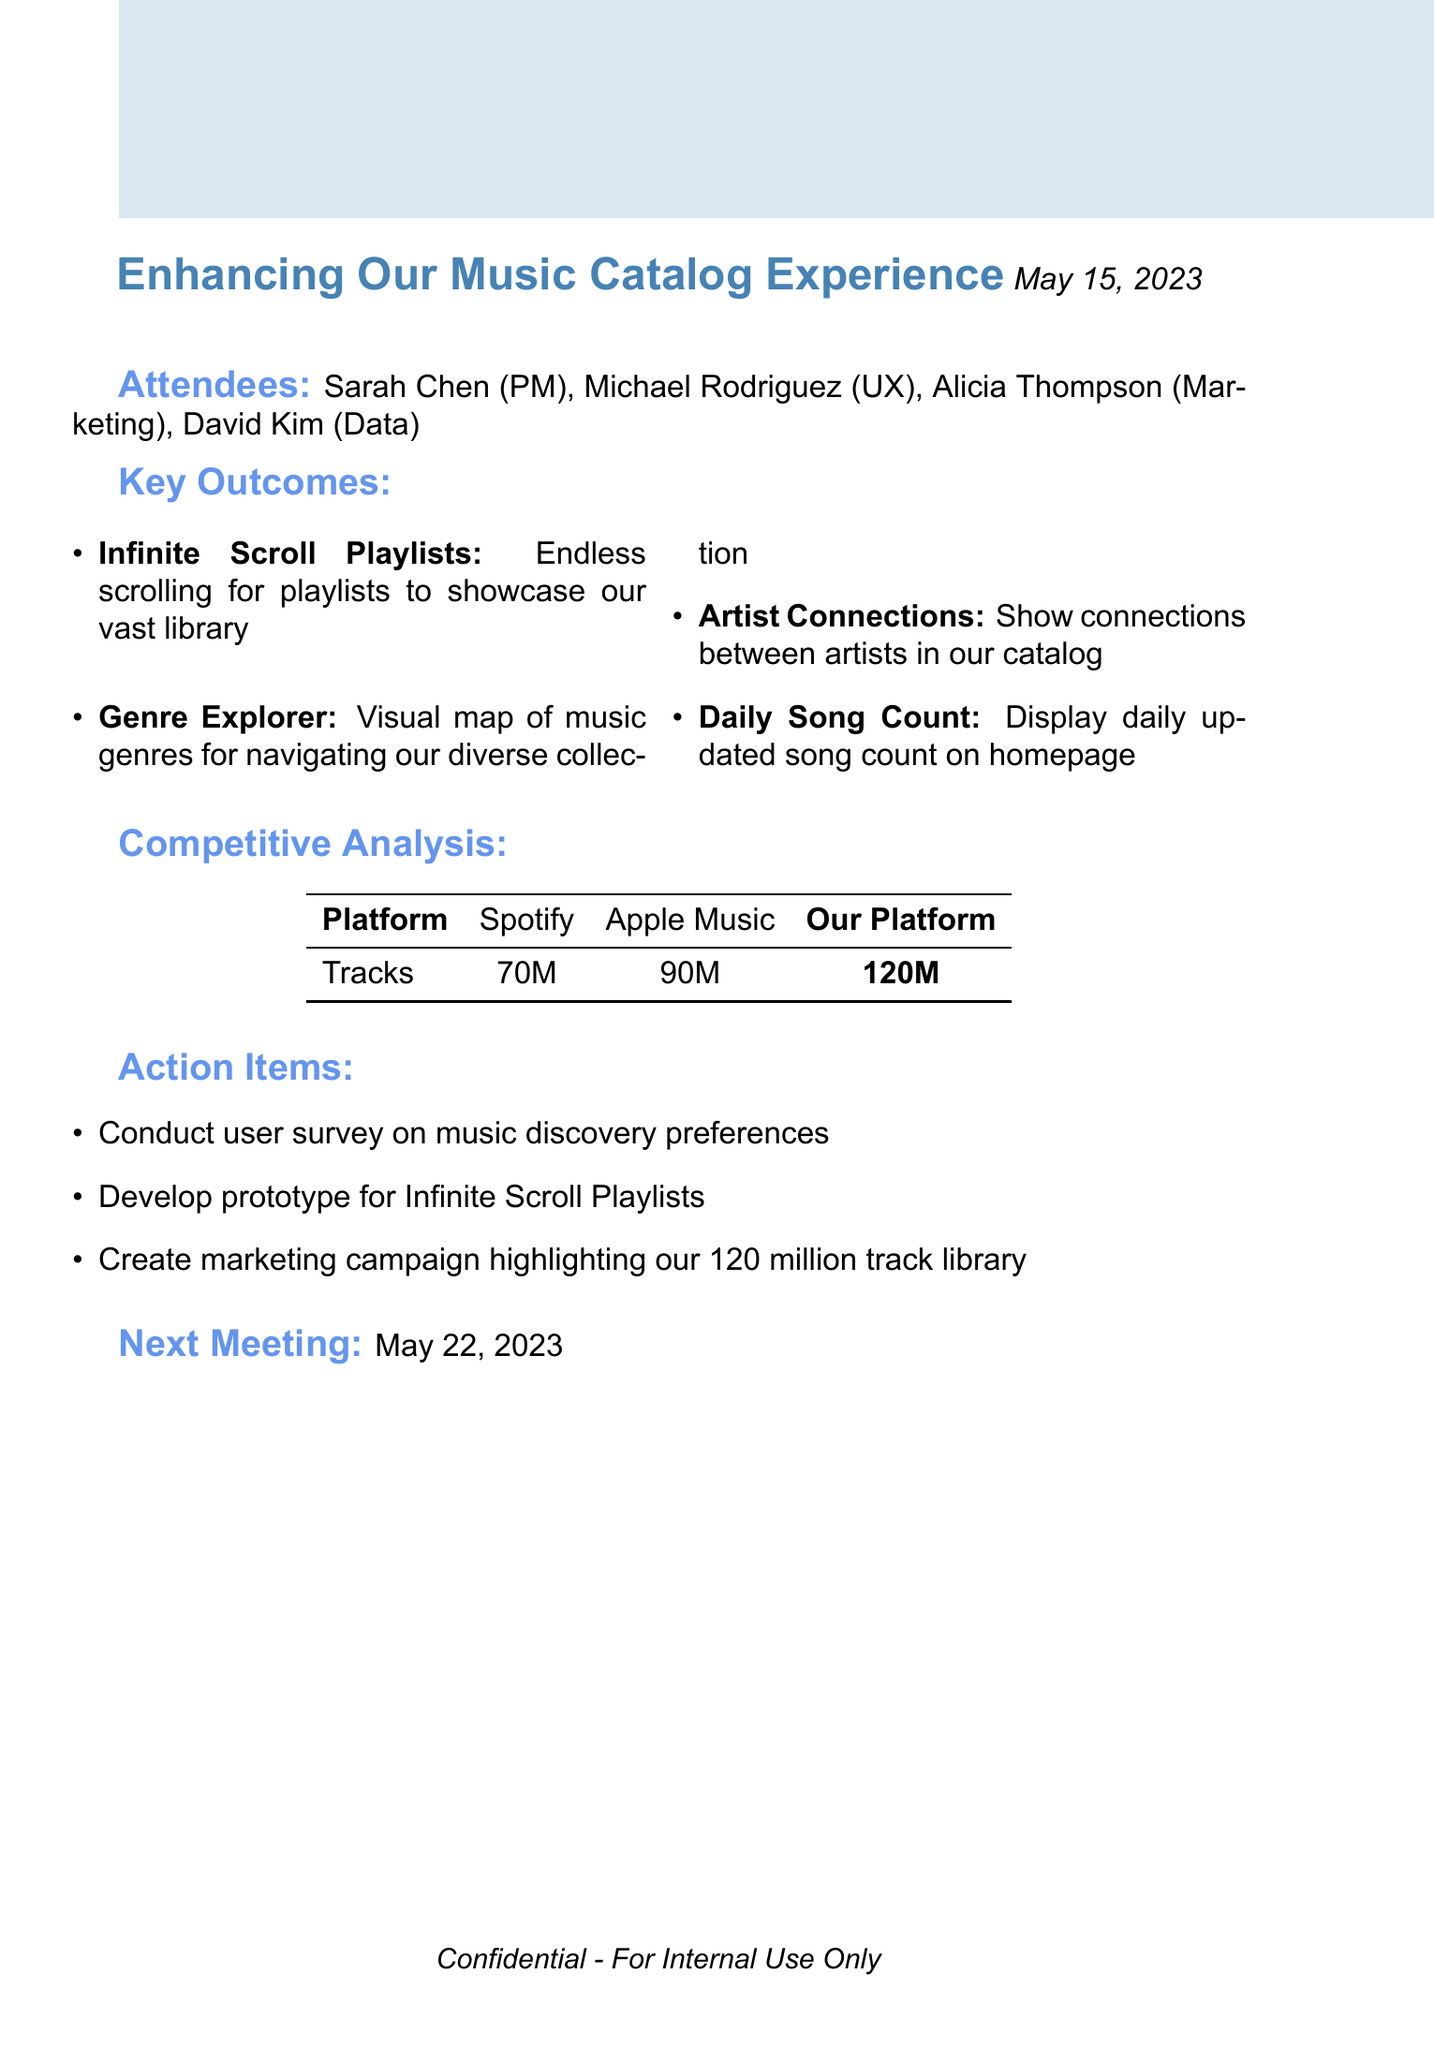What is the session title? The session title is presented prominently at the beginning of the document.
Answer: Enhancing Our Music Catalog Experience Who are the attendees? The attendees are listed in a section that follows the meeting title and date.
Answer: Sarah Chen, Michael Rodriguez, Alicia Thompson, David Kim What date was the brainstorming session held? The date is specified right after the session title.
Answer: May 15, 2023 What is the benefit of the Daily Song Count feature? The benefit is described in relation to how it emphasizes the growing music library.
Answer: Emphasizes our growing library and creates a sense of abundance How many tracks does our platform have? The competitive analysis section shows the number of tracks for each platform including ours.
Answer: 120 million tracks What is one action item from the session? Action items are listed after the main outcomes and provide specific follow-up tasks.
Answer: Conduct user survey on music discovery preferences What is the next meeting date? The next meeting date is noted at the end of the document.
Answer: May 22, 2023 What is the feature that allows users to visually explore music genres? This feature is discussed as one of the key outcomes related to user experience.
Answer: Genre Explorer What does the Artist Connections feature aim to demonstrate? The description of the Artist Connections feature includes its purpose regarding the catalog.
Answer: Demonstrates the depth of our library and encourages exploration 